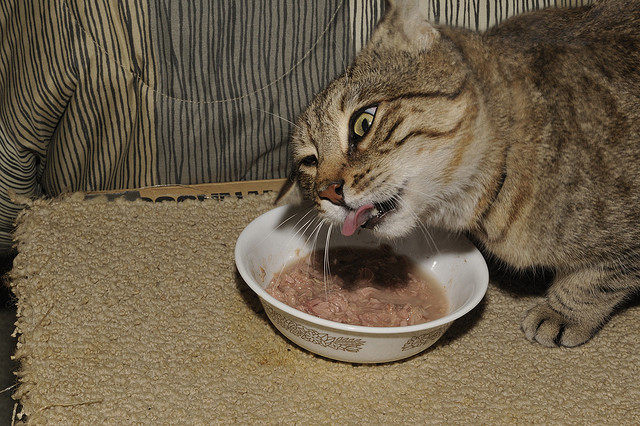<image>What color is the cat's collar? I don't know the color of the cat's collar. It could be black, brown, or the cat may not have a collar at all. What color is the cat's collar? I am not sure what color the cat's collar is. It can be seen black, red and black, or there is none. 